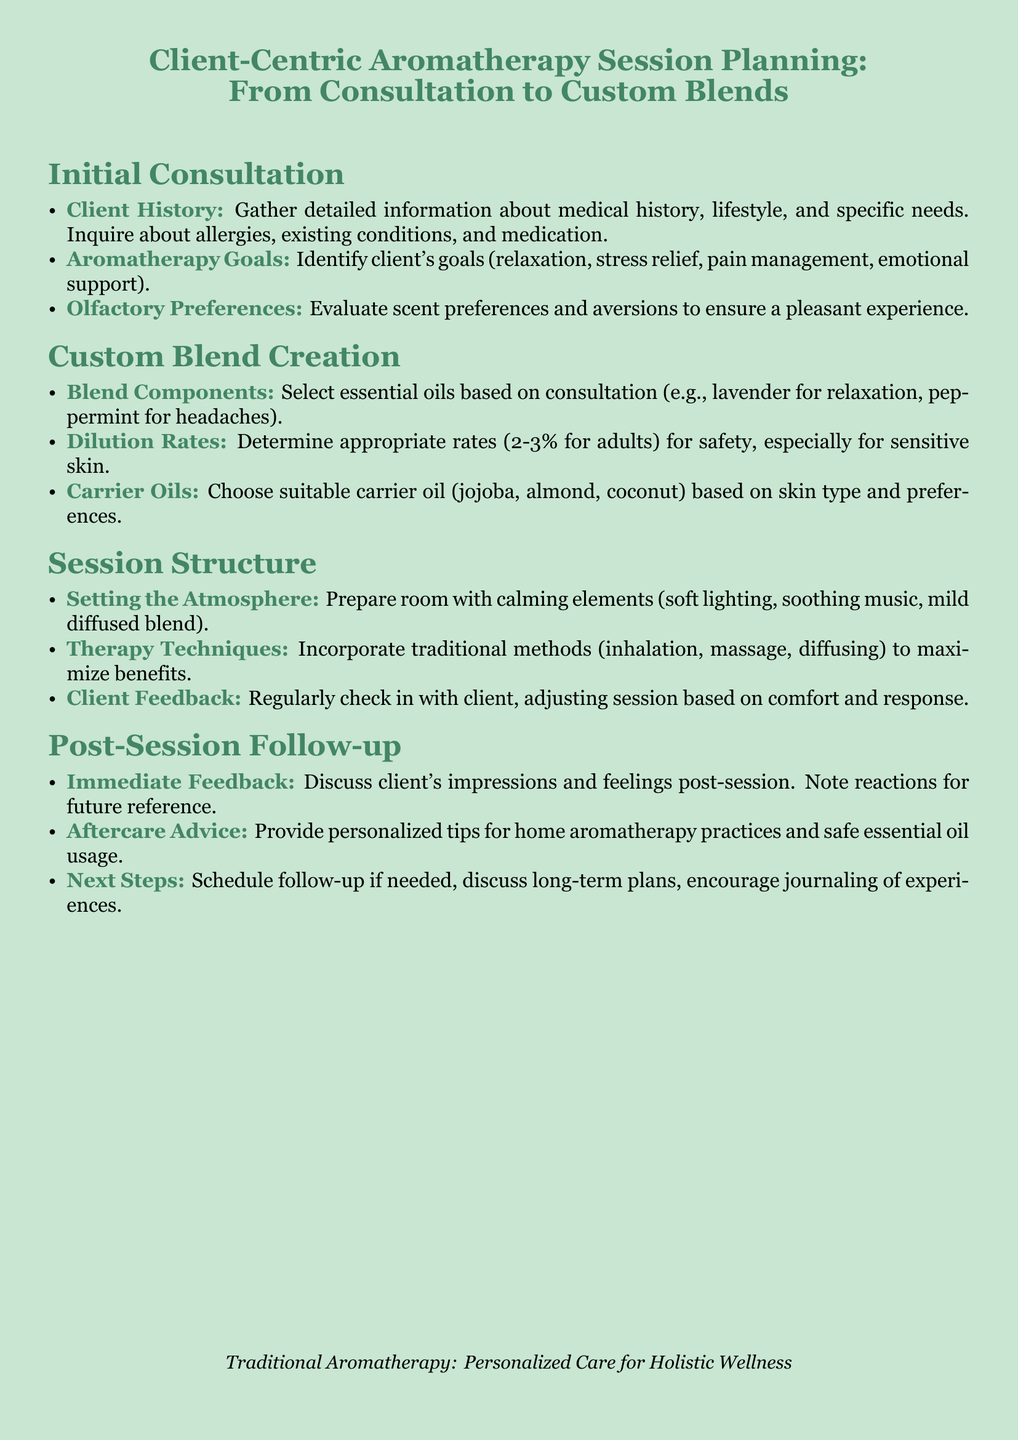What is the primary focus of the document? The primary focus is on planning aromatherapy sessions that are centered around the client's needs and experiences.
Answer: Client-Centric Aromatherapy Session Planning What type of oils should be selected for relaxation? The document specifies lavender essential oil as suitable for relaxation.
Answer: Lavender What should be evaluated regarding scent preferences? The document states that evaluating scent preferences and aversions is essential to ensure a pleasant experience.
Answer: Scent preferences and aversions What is the recommended dilution rate for adults? The document indicates that the appropriate dilution rate for adults is 2-3%.
Answer: 2-3% What is included in the session structure? The session structure includes setting the atmosphere, therapy techniques, and client feedback.
Answer: Setting the Atmosphere, Therapy Techniques, Client Feedback What should be discussed during immediate feedback? The document states that clients should discuss their impressions and feelings post-session.
Answer: Impressions and feelings What type of oils can be chosen as carrier oils? The document lists jojoba, almond, and coconut as suitable carrier oils based on skin type.
Answer: Jojoba, almond, coconut What should clients do for aftercare advice? Clients should be provided with personalized tips for home aromatherapy practices.
Answer: Tips for home aromatherapy practices What should be noted for future reference after a session? The document highlights that client reactions should be noted for future reference.
Answer: Client reactions 